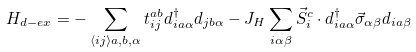Convert formula to latex. <formula><loc_0><loc_0><loc_500><loc_500>H _ { d - e x } = - \sum _ { \langle i j \rangle a , b , \alpha } t _ { i j } ^ { a b } d _ { i a \alpha } ^ { \dagger } d _ { j b \alpha } - J _ { H } \sum _ { i \alpha \beta } \vec { S } _ { i } ^ { c } \cdot d _ { i a \alpha } ^ { \dagger } \vec { \sigma } _ { \alpha \beta } d _ { i a \beta }</formula> 